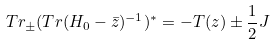Convert formula to latex. <formula><loc_0><loc_0><loc_500><loc_500>T r _ { \pm } ( T r ( H _ { 0 } - \bar { z } ) ^ { - 1 } ) ^ { * } = - T ( z ) \pm \frac { 1 } { 2 } J</formula> 